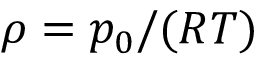Convert formula to latex. <formula><loc_0><loc_0><loc_500><loc_500>\rho = p _ { 0 } / ( R T )</formula> 